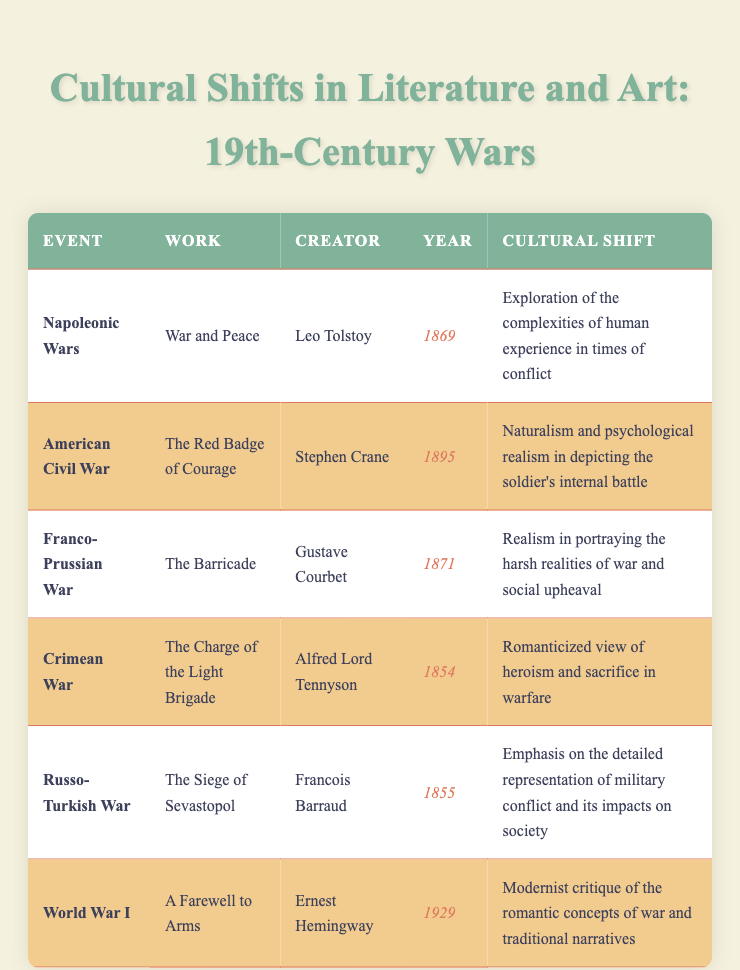What literary work was created during the Napoleonic Wars? The table lists "War and Peace" as the literary work associated with the Napoleonic Wars, authored by Leo Tolstoy in 1869.
Answer: War and Peace Which artist created a work in response to the Franco-Prussian War? According to the table, the artist Gustave Courbet created "The Barricade" in 1871 in response to the Franco-Prussian War.
Answer: Gustave Courbet What is the cultural shift associated with "The Red Badge of Courage"? The table indicates that "The Red Badge of Courage" reflects a cultural shift towards naturalism and psychological realism, particularly in depicting the soldier's internal battle.
Answer: Naturalism and psychological realism True or False: "The Charge of the Light Brigade" was created before the American Civil War. The table shows that "The Charge of the Light Brigade" was published in 1854, which is indeed before the American Civil War (1861-1865).
Answer: True What is the average year of publication for the literary works listed in the table? The years of publication for the literary works are 1869, 1895, 1854, and 1929. Adding them up gives 1869 + 1895 + 1854 + 1929 = 7447. There are 4 works, so the average year is 7447 / 4 = 1861.75, rounded to 1862.
Answer: 1862 What cultural shift does "The Siege of Sevastopol" emphasize? According to the table, "The Siege of Sevastopol" emphasizes a detailed representation of military conflict and its impacts on society.
Answer: Detailed representation of military conflict True or False: The work "A Farewell to Arms" is directly related to World War I. The table notes that "A Farewell to Arms" is associated with World War I, thus this statement is correct.
Answer: True Which event is associated with the year 1855? The table indicates that the Russo-Turkish War is associated with the year 1855.
Answer: Russo-Turkish War What is the cultural shift associated with the artwork "The Barricade"? The table states that "The Barricade" represents realism in depicting the harsh realities of war and social upheaval, denoting a significant cultural shift.
Answer: Realism in portraying harsh realities of war 